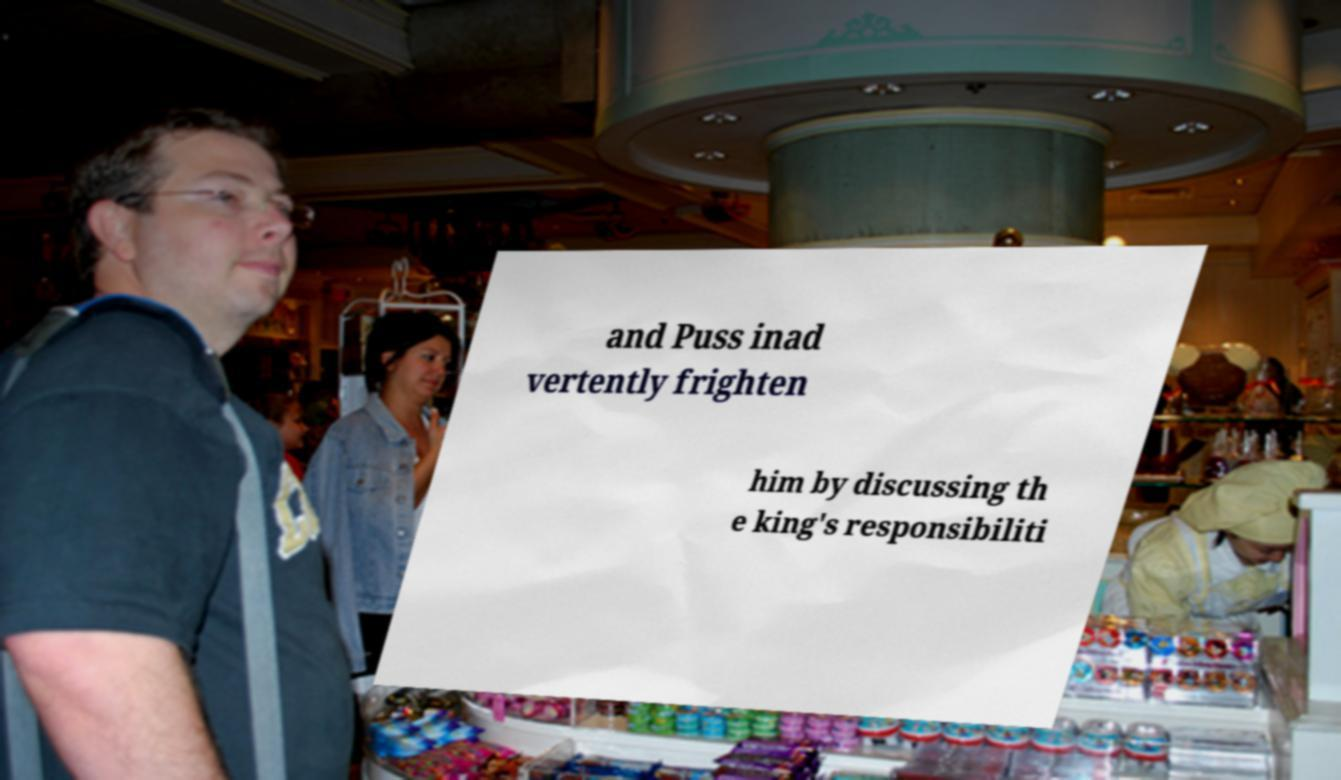Can you read and provide the text displayed in the image?This photo seems to have some interesting text. Can you extract and type it out for me? and Puss inad vertently frighten him by discussing th e king's responsibiliti 